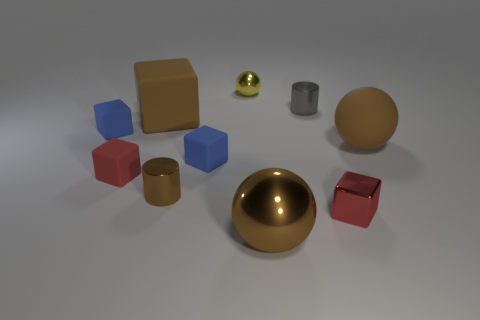Subtract all red rubber cubes. How many cubes are left? 4 Subtract all brown cubes. How many cubes are left? 4 Subtract all purple blocks. Subtract all red cylinders. How many blocks are left? 5 Subtract all balls. How many objects are left? 7 Subtract all brown things. Subtract all gray cylinders. How many objects are left? 5 Add 6 gray metal objects. How many gray metal objects are left? 7 Add 5 red cubes. How many red cubes exist? 7 Subtract 0 blue balls. How many objects are left? 10 